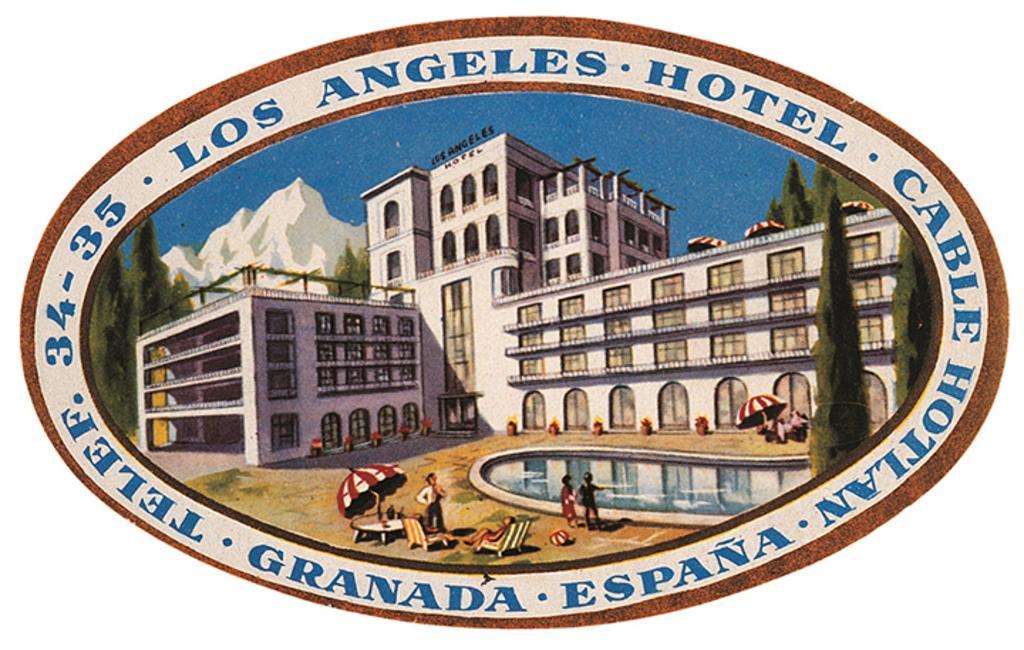Describe this image in one or two sentences. In this picture there is a poster. In the center I can see the cartoon images of the building, trees, mountain, snow, sky, swimming pool, person, umbrella, table and chairs. 